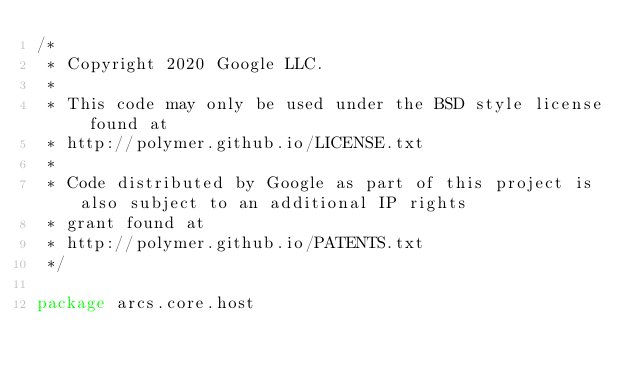Convert code to text. <code><loc_0><loc_0><loc_500><loc_500><_Kotlin_>/*
 * Copyright 2020 Google LLC.
 *
 * This code may only be used under the BSD style license found at
 * http://polymer.github.io/LICENSE.txt
 *
 * Code distributed by Google as part of this project is also subject to an additional IP rights
 * grant found at
 * http://polymer.github.io/PATENTS.txt
 */

package arcs.core.host
</code> 